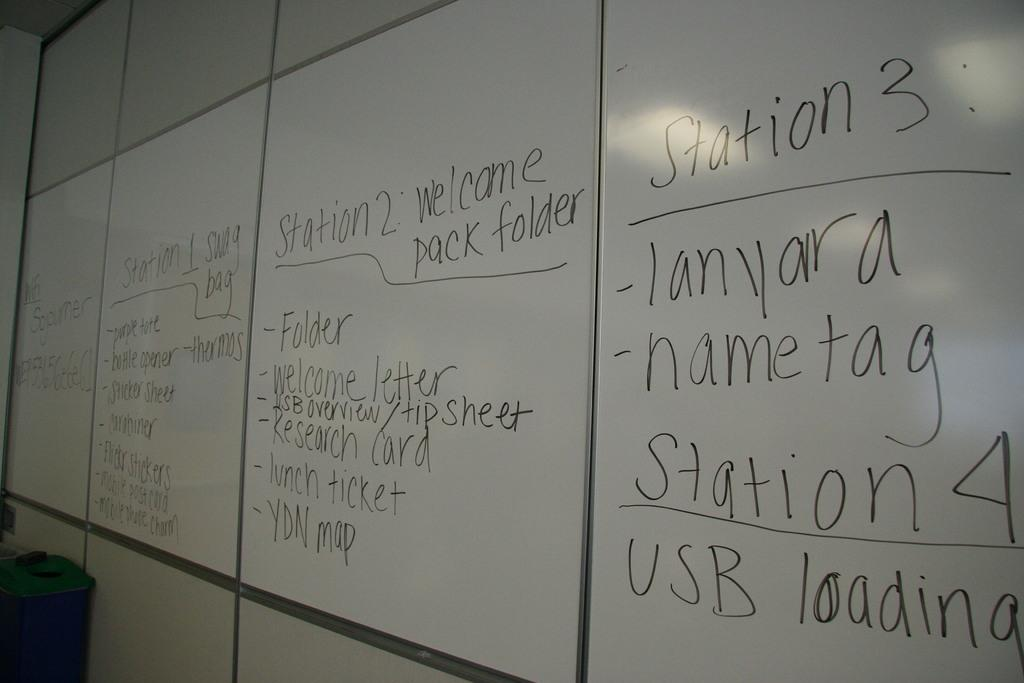What is the primary color of the board in the image? The board in the image is white. What color is used to write on the board? Something is written on the board with black color. Can you describe the blue object in the image? There is an object in blue color in the image. How many actors are present in the image? There are no actors present in the image. What are the girls doing in the image? There are no girls present in the image. 